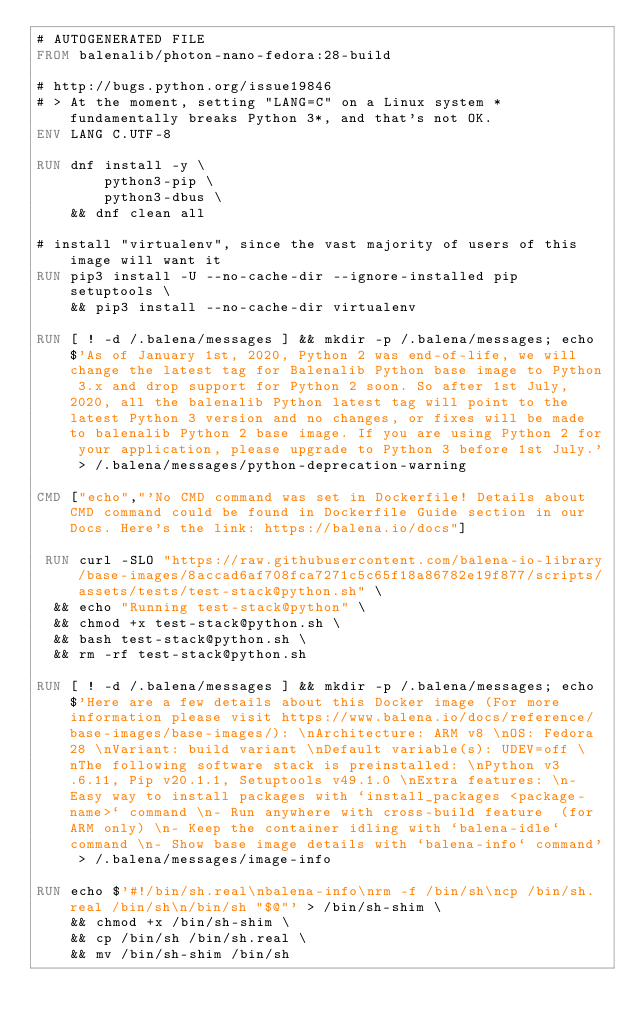Convert code to text. <code><loc_0><loc_0><loc_500><loc_500><_Dockerfile_># AUTOGENERATED FILE
FROM balenalib/photon-nano-fedora:28-build

# http://bugs.python.org/issue19846
# > At the moment, setting "LANG=C" on a Linux system *fundamentally breaks Python 3*, and that's not OK.
ENV LANG C.UTF-8

RUN dnf install -y \
		python3-pip \
		python3-dbus \
	&& dnf clean all

# install "virtualenv", since the vast majority of users of this image will want it
RUN pip3 install -U --no-cache-dir --ignore-installed pip setuptools \
	&& pip3 install --no-cache-dir virtualenv

RUN [ ! -d /.balena/messages ] && mkdir -p /.balena/messages; echo $'As of January 1st, 2020, Python 2 was end-of-life, we will change the latest tag for Balenalib Python base image to Python 3.x and drop support for Python 2 soon. So after 1st July, 2020, all the balenalib Python latest tag will point to the latest Python 3 version and no changes, or fixes will be made to balenalib Python 2 base image. If you are using Python 2 for your application, please upgrade to Python 3 before 1st July.' > /.balena/messages/python-deprecation-warning

CMD ["echo","'No CMD command was set in Dockerfile! Details about CMD command could be found in Dockerfile Guide section in our Docs. Here's the link: https://balena.io/docs"]

 RUN curl -SLO "https://raw.githubusercontent.com/balena-io-library/base-images/8accad6af708fca7271c5c65f18a86782e19f877/scripts/assets/tests/test-stack@python.sh" \
  && echo "Running test-stack@python" \
  && chmod +x test-stack@python.sh \
  && bash test-stack@python.sh \
  && rm -rf test-stack@python.sh 

RUN [ ! -d /.balena/messages ] && mkdir -p /.balena/messages; echo $'Here are a few details about this Docker image (For more information please visit https://www.balena.io/docs/reference/base-images/base-images/): \nArchitecture: ARM v8 \nOS: Fedora 28 \nVariant: build variant \nDefault variable(s): UDEV=off \nThe following software stack is preinstalled: \nPython v3.6.11, Pip v20.1.1, Setuptools v49.1.0 \nExtra features: \n- Easy way to install packages with `install_packages <package-name>` command \n- Run anywhere with cross-build feature  (for ARM only) \n- Keep the container idling with `balena-idle` command \n- Show base image details with `balena-info` command' > /.balena/messages/image-info

RUN echo $'#!/bin/sh.real\nbalena-info\nrm -f /bin/sh\ncp /bin/sh.real /bin/sh\n/bin/sh "$@"' > /bin/sh-shim \
	&& chmod +x /bin/sh-shim \
	&& cp /bin/sh /bin/sh.real \
	&& mv /bin/sh-shim /bin/sh</code> 